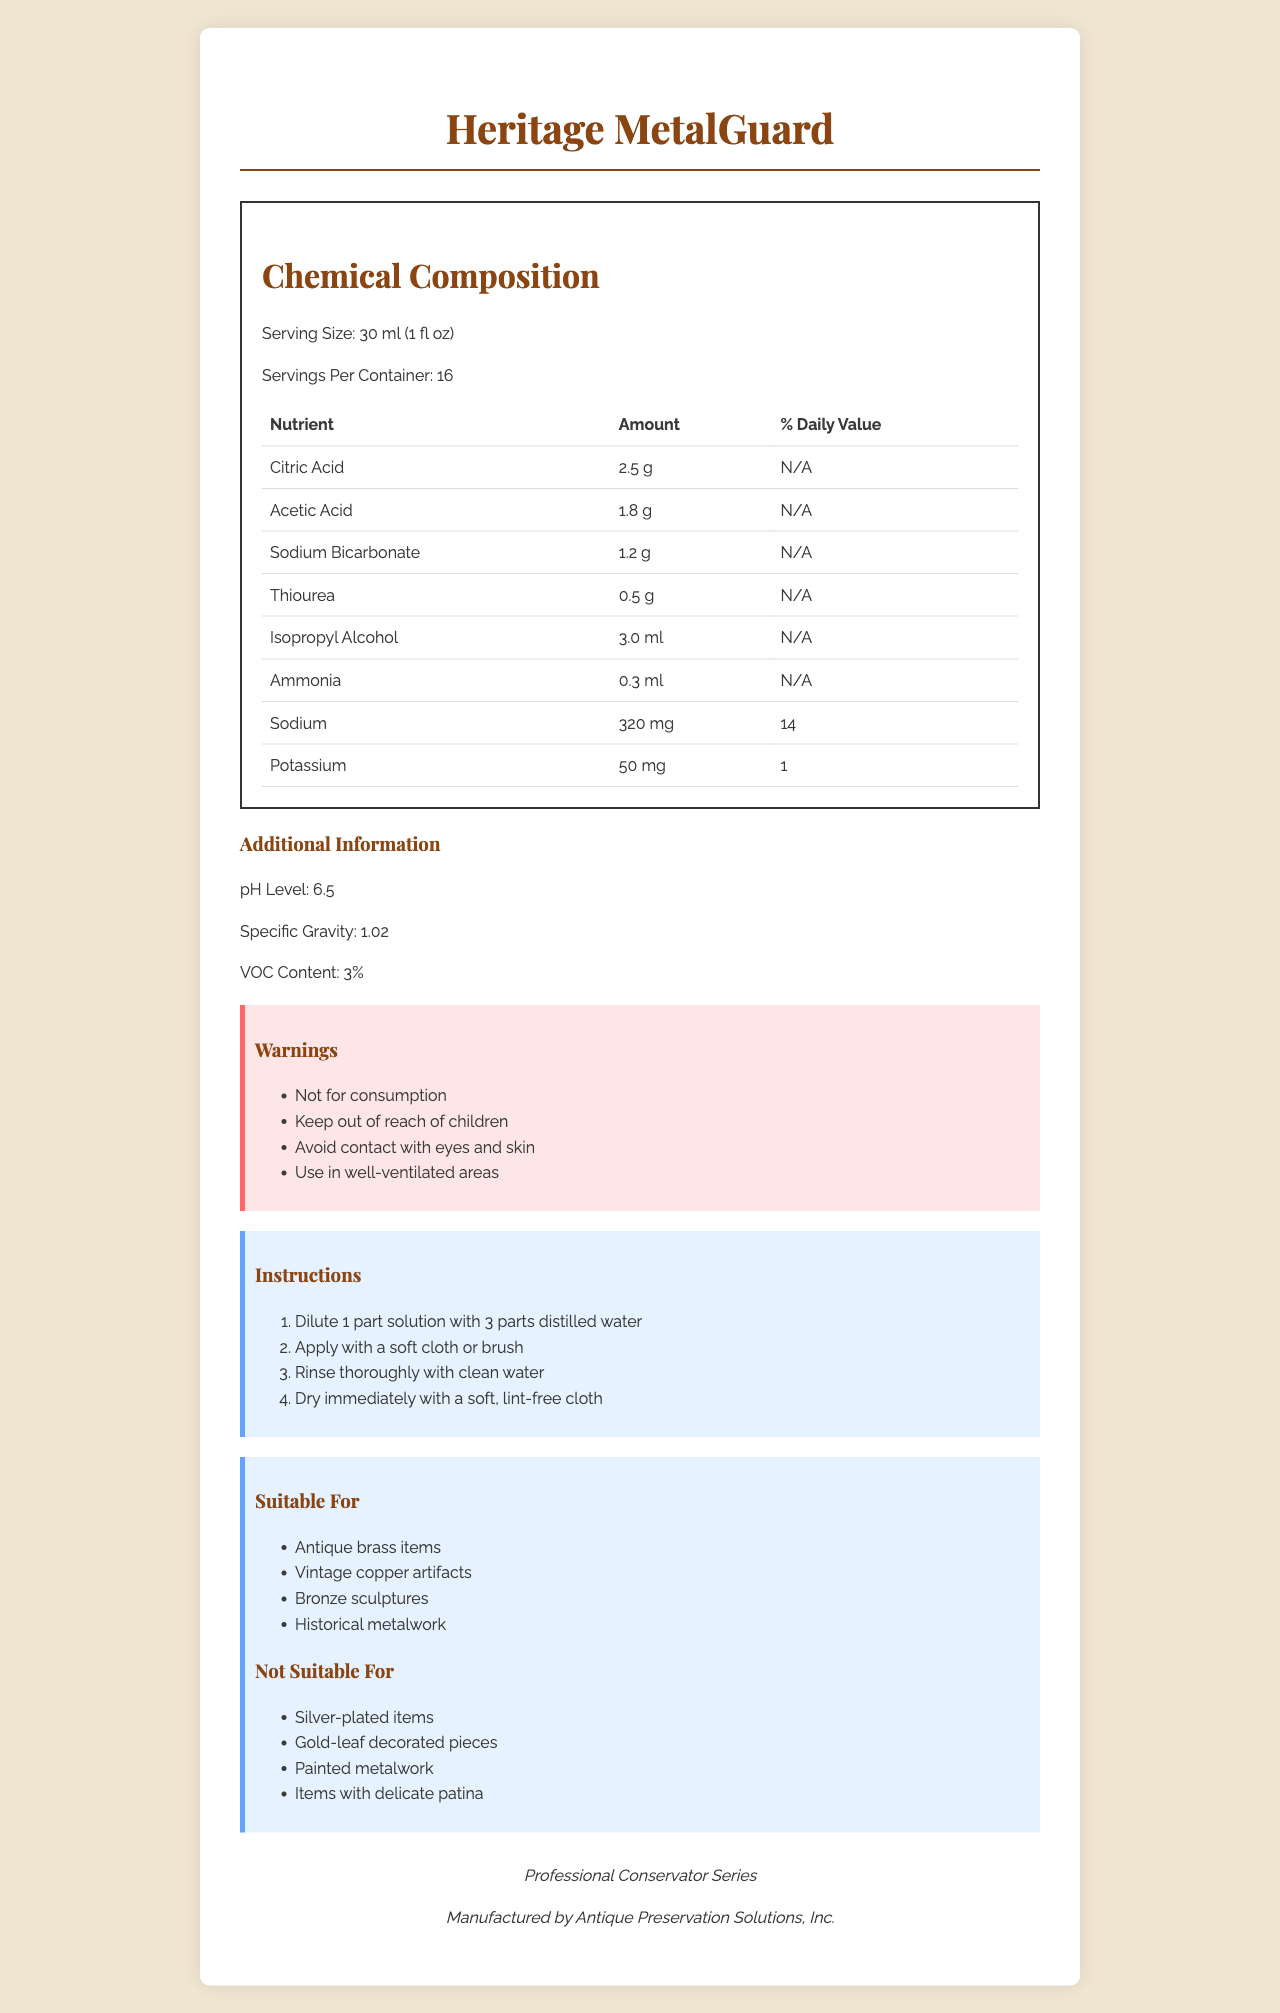how many servings are in the container? The document states that there are 16 servings per container.
Answer: 16 what is the pH level of the cleaning solution? The pH Level is listed in the Additional Information section as 6.5.
Answer: 6.5 how much Citric Acid is in one serving? The nutrient table shows Citric Acid - 2.5 g per serving.
Answer: 2.5 g what is one thing this cleaning solution should not come into contact with? In the Warnings section, it states "Avoid contact with eyes and skin."
Answer: Eyes what percentage of the daily value for Sodium does one serving contain? The nutrient table indicates that one serving has 14% of the daily value for Sodium.
Answer: 14% which substance has the highest amount in one serving of the cleaning solution? A. Citric Acid B. Acetic Acid C. Sodium Bicarbonate D. Isopropyl Alcohol Isopropyl Alcohol has the highest amount in one serving with 3.0 ml.
Answer: D this cleaning solution is not suitable for which of the following? I. Antique brass items II. Silver-plated items III. Gold-leaf decorated pieces IV. Vintage copper artifacts The "Not Suitable For" section states that the cleaning solution is not suitable for Silver-plated items and Gold-leaf decorated pieces.
Answer: II and III is this cleaning solution safe for consumption? The warning section specifically states "Not for consumption."
Answer: No summarize the main idea of this document. The document includes detailed information about the ingredients in the cleaning solution, its usage instructions, safety warnings, and which items it is suitable or not suitable to clean.
Answer: This label provides nutritional and chemical information about a cleaning solution for antique brass and copper, including serving size, chemical composition, warnings, instructions, and suitability for use. what is the specific gravity of the cleaning solution? The section labeled Additional Information states the Specific Gravity as 1.02.
Answer: 1.02 what is the dilution ratio recommended for this cleaning solution? The Instructions section mentions using a ratio of 1 part solution to 3 parts distilled water.
Answer: 1 part solution to 3 parts distilled water how much Sodium Bicarbonate is present in two servings of the solution? Each serving contains 1.2 g, so two servings contain 2.4 g of Sodium Bicarbonate.
Answer: 2.4 g who manufactures the Heritage MetalGuard cleaning solution? The brand information section at the end of the document states the manufacturer is Antique Preservation Solutions, Inc.
Answer: Antique Preservation Solutions, Inc. is this cleaning solution suitable for bronze sculptures? The Suitable For section lists bronze sculptures as appropriate for this cleaning solution.
Answer: Yes what are the steps for applying this cleaning solution onto an artifact? The Instructions section provides a step-by-step guide on how to apply the cleaning solution.
Answer: Dilute 1 part solution with 3 parts distilled water, apply with a soft cloth or brush, rinse thoroughly with clean water, and dry immediately with a soft, lint-free cloth. can you drink this solution if diluted? The document clearly states that the solution is not for consumption, whether diluted or not.
Answer: Not enough information 